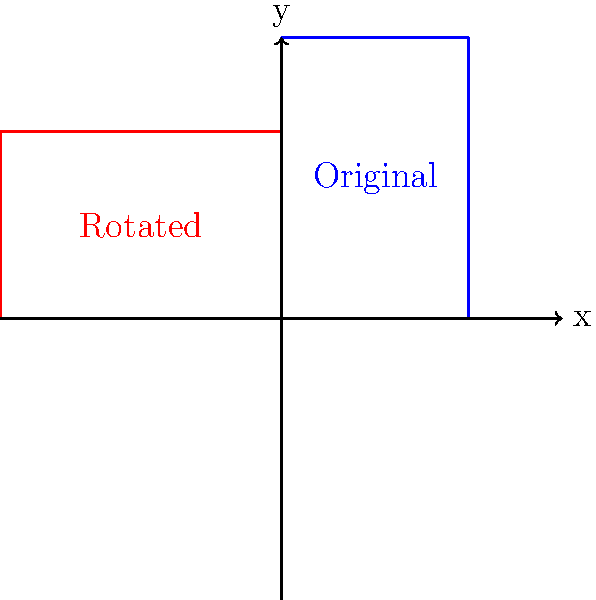A hospital is considering rotating its rectangular floor plan by 90 degrees counterclockwise to optimize space efficiency. The original floor plan measures 4 units wide and 6 units long. After the rotation, what will be the new coordinates of the top-right corner of the floor plan? To solve this problem, we need to follow these steps:

1. Identify the original coordinates:
   The original top-right corner is at (4, 6).

2. Understand the rotation:
   A 90-degree counterclockwise rotation around the origin can be achieved by applying the transformation:
   $$(x, y) \rightarrow (-y, x)$$

3. Apply the transformation:
   For the point (4, 6):
   $x_{new} = -y = -6$
   $y_{new} = x = 4$

4. Therefore, the new coordinates are (-6, 4).

This transformation effectively rotates the floor plan, making the original width (4 units) the new height, and the original length (6 units) the new width, but in the negative x-direction.
Answer: (-6, 4) 